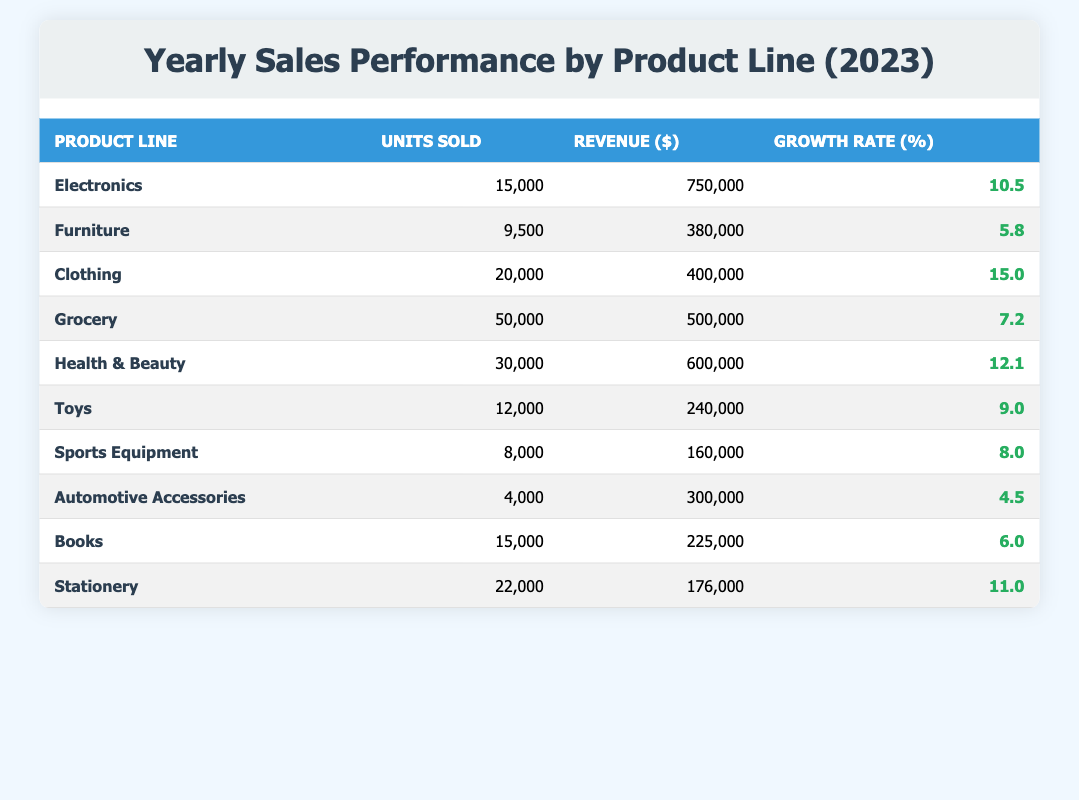What is the product line with the highest units sold? Looking at the "Units Sold" column, Grocery has the highest value at 50,000 units sold, which is more than any other product line.
Answer: Grocery Which product line generated the most revenue in 2023? By examining the "Revenue" column, Electronics has the highest revenue, totaling $750,000, more than any other product line.
Answer: Electronics How many units were sold for the Clothing product line? The table indicates that the Clothing product line sold 20,000 units, as noted in the "Units Sold" column.
Answer: 20,000 What is the growth rate for Health & Beauty products? In the "Growth Rate" column, the growth rate for Health & Beauty is listed as 12.1%.
Answer: 12.1% What is the average growth rate of all product lines? The growth rates are 10.5, 5.8, 15.0, 7.2, 12.1, 9.0, 8.0, 4.5, 6.0, and 11.0. The total is 10.1, and there are 10 product lines. So, the average growth rate is 10.1/10 = 10.1%.
Answer: 10.1% Is the growth rate of Toys higher than that of Automotive Accessories? The growth rate for Toys is 9.0%, while for Automotive Accessories, it is 4.5%. Since 9.0% is greater than 4.5%, the statement is true.
Answer: Yes What is the combined total revenue of Electronics and Health & Beauty? The revenue for Electronics is $750,000, and for Health & Beauty, it is $600,000. Adding these: $750,000 + $600,000 = $1,350,000.
Answer: $1,350,000 Which product lines had a growth rate below 8%? The growth rates below 8% are Automotive Accessories at 4.5%. Therefore, only Automotive Accessories qualifies.
Answer: Automotive Accessories What was the revenue difference between Clothing and Toys? Clothing revenue is $400,000, and Toys is $240,000. The difference is $400,000 - $240,000 = $160,000.
Answer: $160,000 How many product lines sold more than 15,000 units? The product lines that sold more than 15,000 units are Grocery (50,000), Health & Beauty (30,000), Clothing (20,000), and Stationery (22,000). This totals to four product lines.
Answer: 4 